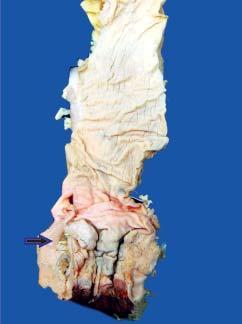how does the anorectal margin show an ulcerated mucosa?
Answer the question using a single word or phrase. With thickened wall 